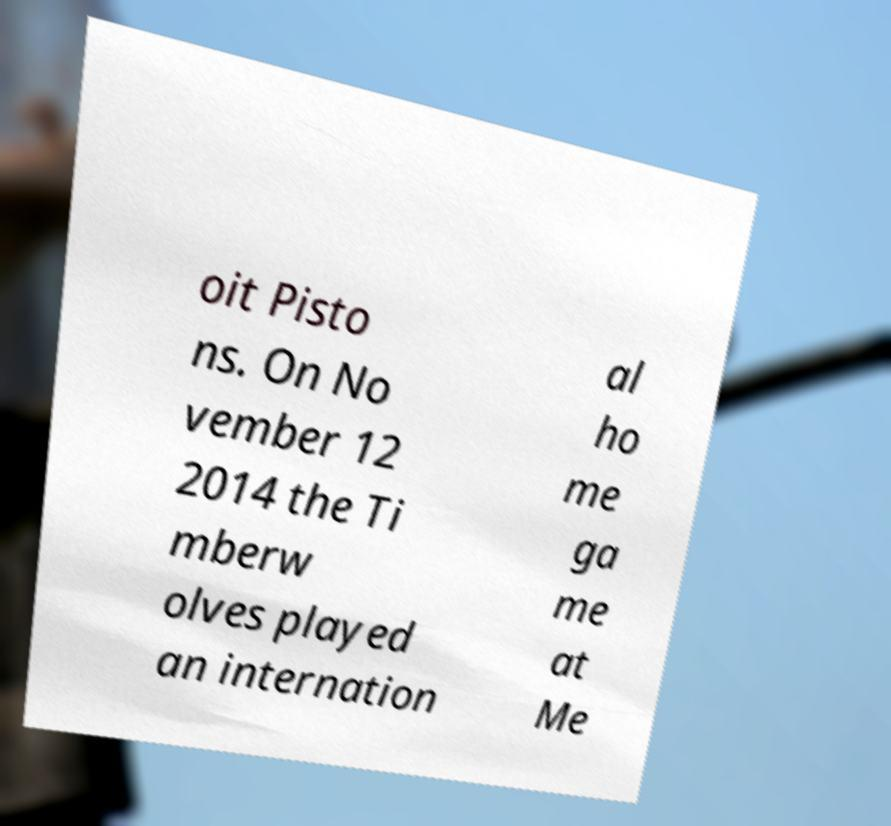Can you accurately transcribe the text from the provided image for me? oit Pisto ns. On No vember 12 2014 the Ti mberw olves played an internation al ho me ga me at Me 